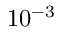<formula> <loc_0><loc_0><loc_500><loc_500>1 0 ^ { - 3 }</formula> 